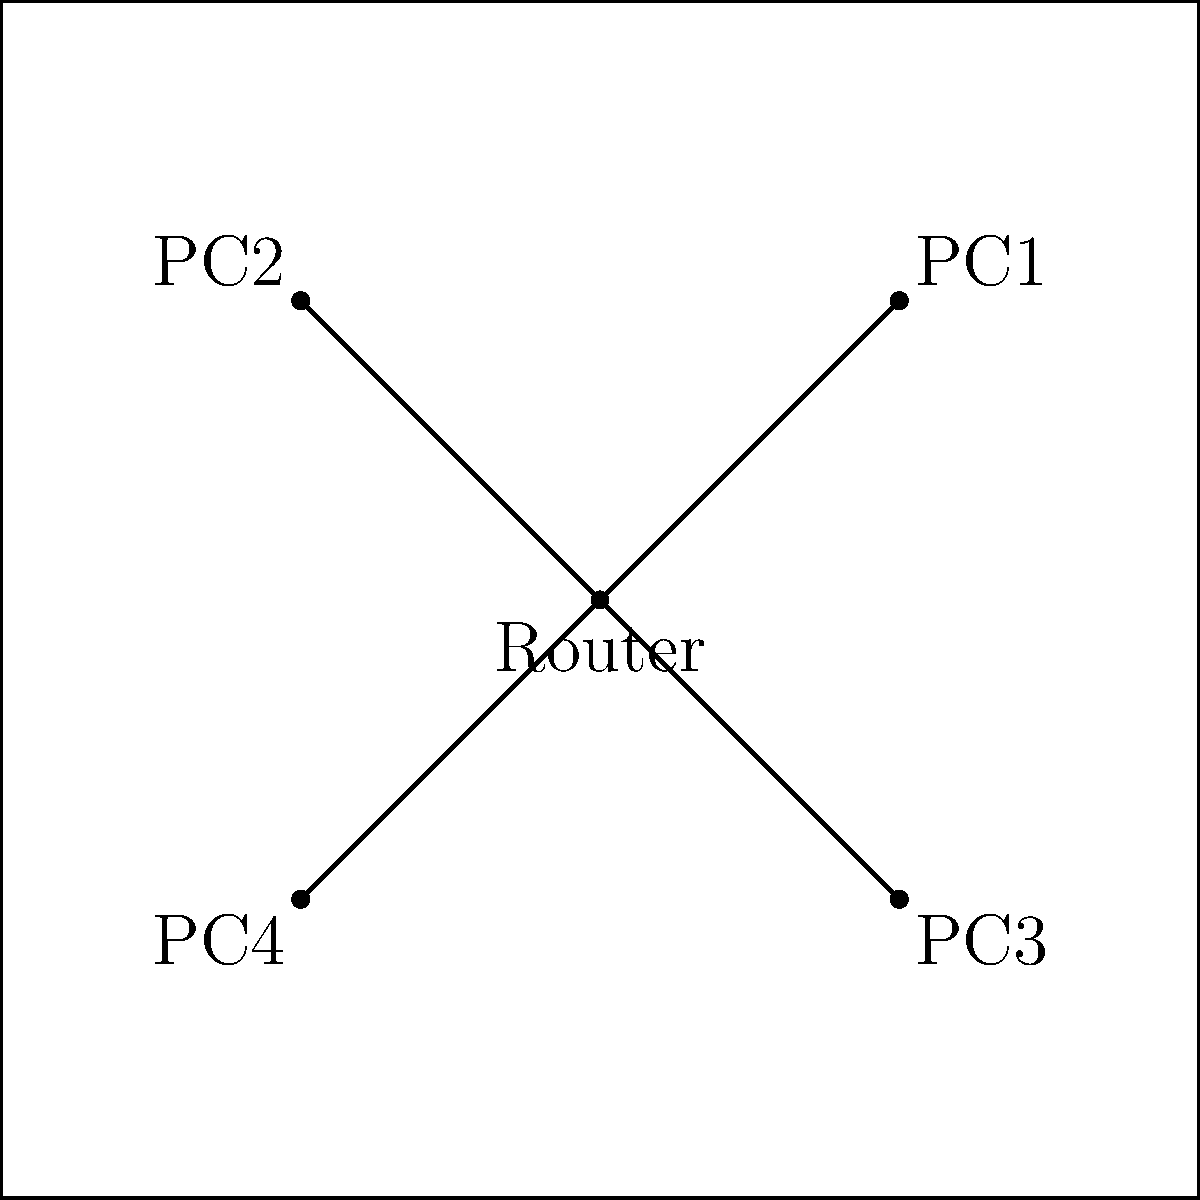In designing a cost-effective network infrastructure for a small X-COM base, which topology is represented in the diagram, and why would it be a suitable choice for a budget-conscious setup? To determine the most suitable and cost-effective network topology for a small X-COM base, let's analyze the diagram step-by-step:

1. Observe the network structure:
   - There is a central device (labeled "Router") connected to four other devices (labeled PC1, PC2, PC3, and PC4).
   - All connections originate from the central device.

2. Identify the topology:
   - This structure represents a star topology.

3. Advantages of star topology for a small X-COM base on a budget:
   a) Centralized management: Easy to monitor and control network traffic from a single point.
   b) Scalability: New devices can be added without disrupting the entire network.
   c) Fault isolation: If one connection fails, it doesn't affect the others.
   d) Cost-effective for small networks: Requires less cabling compared to other topologies like mesh.

4. Budget considerations:
   - Uses a single router, reducing hardware costs.
   - Minimizes cable length, lowering infrastructure expenses.
   - Simplified troubleshooting reduces maintenance costs.

5. Relevance to X-COM gameplay:
   - Centralized control mirrors the command structure in X-COM.
   - Easy to secure, aligning with the game's emphasis on base defense.
   - Allows for quick information sharing between different base sections.

Therefore, the star topology is an excellent choice for a small X-COM base on a budget, offering a balance between functionality, expandability, and cost-effectiveness.
Answer: Star topology; cost-effective, centralized management, and easily scalable. 